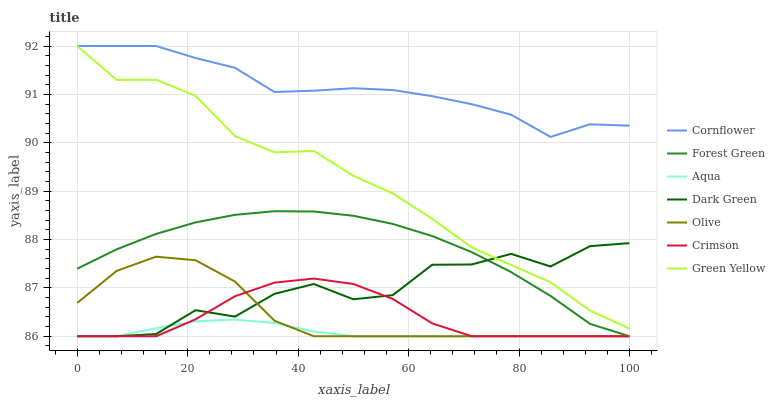Does Crimson have the minimum area under the curve?
Answer yes or no. No. Does Crimson have the maximum area under the curve?
Answer yes or no. No. Is Crimson the smoothest?
Answer yes or no. No. Is Crimson the roughest?
Answer yes or no. No. Does Green Yellow have the lowest value?
Answer yes or no. No. Does Crimson have the highest value?
Answer yes or no. No. Is Olive less than Cornflower?
Answer yes or no. Yes. Is Cornflower greater than Crimson?
Answer yes or no. Yes. Does Olive intersect Cornflower?
Answer yes or no. No. 